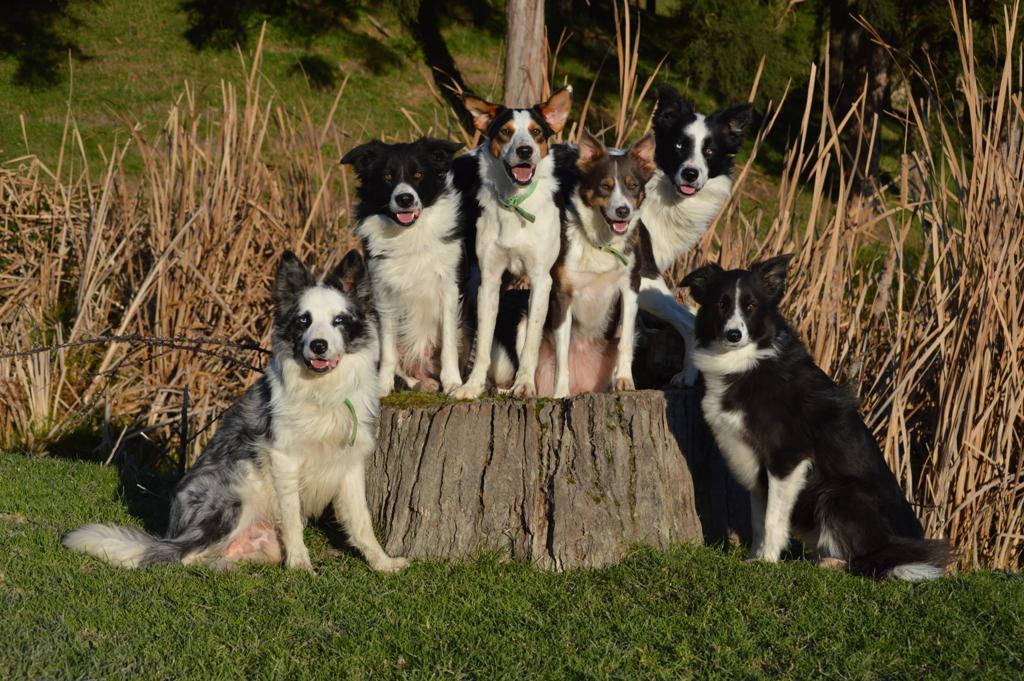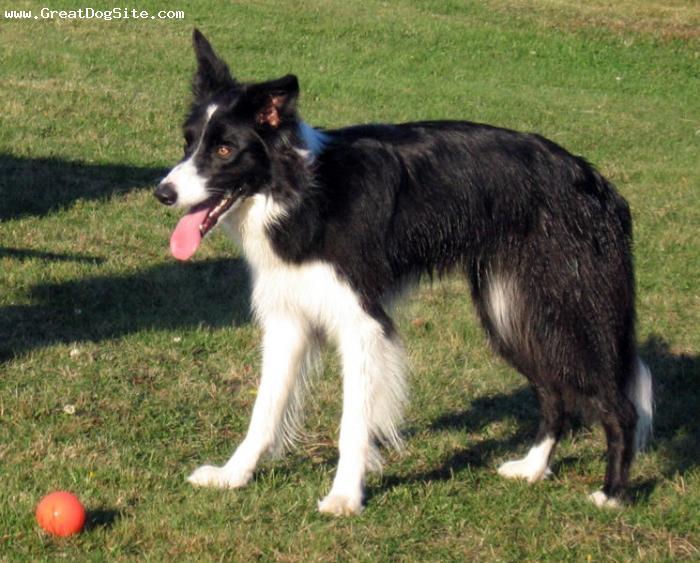The first image is the image on the left, the second image is the image on the right. Evaluate the accuracy of this statement regarding the images: "One image contains four or more dogs that are grouped together in a pose.". Is it true? Answer yes or no. Yes. The first image is the image on the left, the second image is the image on the right. Considering the images on both sides, is "Some of the dogs are sitting down." valid? Answer yes or no. Yes. 